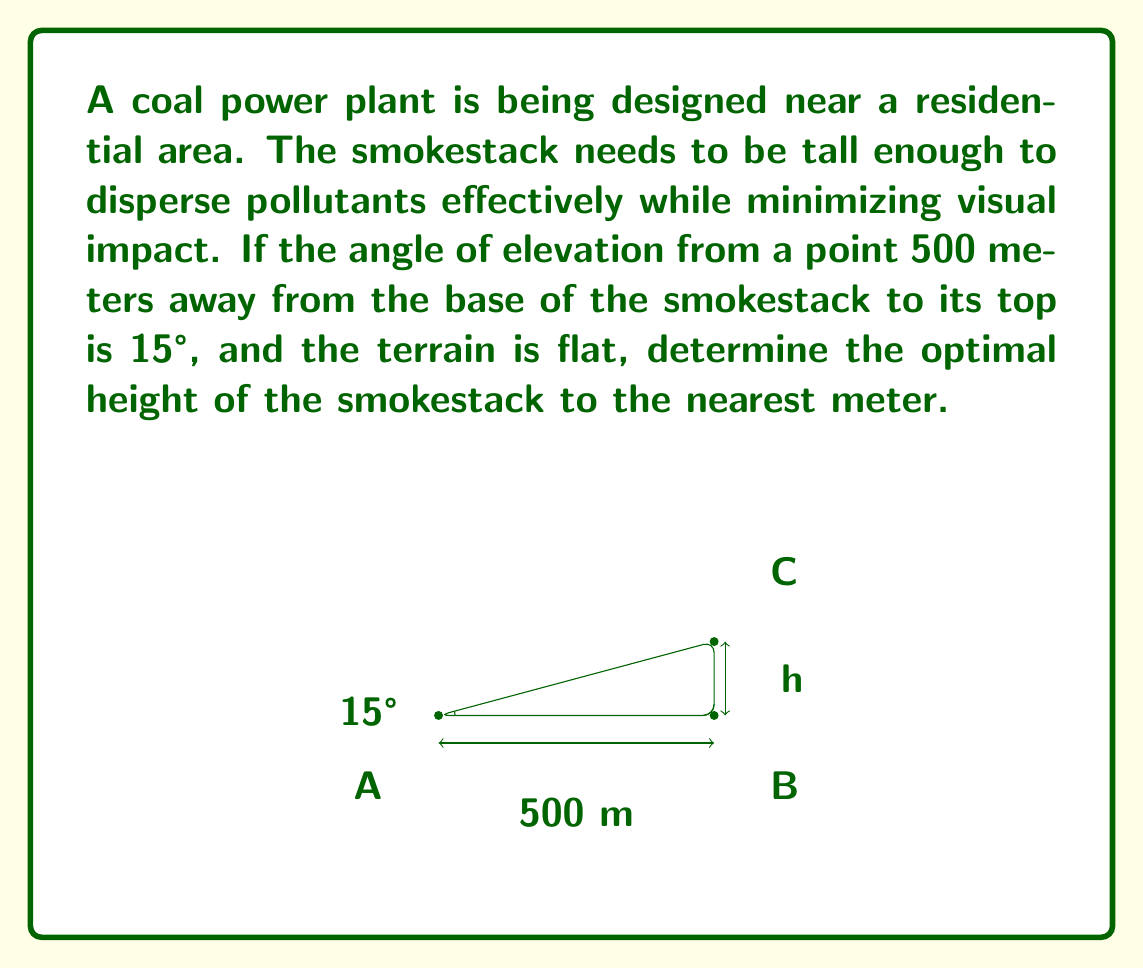Can you answer this question? To solve this problem, we'll use basic trigonometry. Let's break it down step by step:

1) In the right triangle formed by the smokestack, its base, and the line of sight, we know:
   - The adjacent side (distance from the observer to the base) is 500 meters
   - The angle of elevation is 15°
   - We need to find the opposite side (height of the smokestack)

2) The tangent function relates the opposite and adjacent sides in a right triangle:

   $$ \tan(\theta) = \frac{\text{opposite}}{\text{adjacent}} $$

3) Substituting our known values:

   $$ \tan(15°) = \frac{h}{500} $$

   Where $h$ is the height of the smokestack.

4) To solve for $h$, we multiply both sides by 500:

   $$ 500 \cdot \tan(15°) = h $$

5) Now we can calculate:
   
   $$ h = 500 \cdot \tan(15°) $$
   $$ h = 500 \cdot 0.26794... $$
   $$ h = 133.97... \text{ meters} $$

6) Rounding to the nearest meter as requested:

   $$ h \approx 134 \text{ meters} $$

This height allows for effective dispersion of pollutants while maintaining a balance with visual impact concerns, aligning with the perspective of a proponent of traditional energy sources.
Answer: The optimal height of the coal power plant smokestack is approximately 134 meters. 